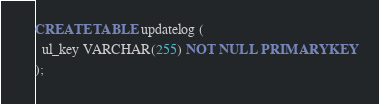Convert code to text. <code><loc_0><loc_0><loc_500><loc_500><_SQL_>CREATE TABLE updatelog (
  ul_key VARCHAR(255) NOT NULL PRIMARY KEY
);
</code> 